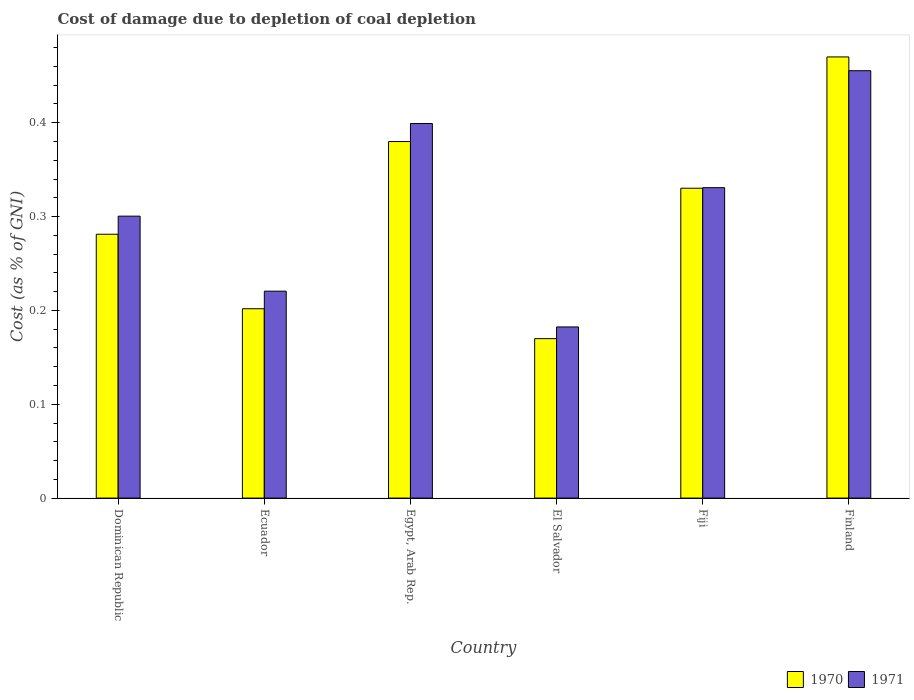How many different coloured bars are there?
Make the answer very short. 2. Are the number of bars per tick equal to the number of legend labels?
Ensure brevity in your answer.  Yes. Are the number of bars on each tick of the X-axis equal?
Give a very brief answer. Yes. How many bars are there on the 3rd tick from the left?
Your answer should be very brief. 2. How many bars are there on the 6th tick from the right?
Give a very brief answer. 2. What is the label of the 4th group of bars from the left?
Your answer should be very brief. El Salvador. In how many cases, is the number of bars for a given country not equal to the number of legend labels?
Make the answer very short. 0. What is the cost of damage caused due to coal depletion in 1971 in Egypt, Arab Rep.?
Provide a succinct answer. 0.4. Across all countries, what is the maximum cost of damage caused due to coal depletion in 1970?
Ensure brevity in your answer.  0.47. Across all countries, what is the minimum cost of damage caused due to coal depletion in 1970?
Offer a terse response. 0.17. In which country was the cost of damage caused due to coal depletion in 1971 maximum?
Make the answer very short. Finland. In which country was the cost of damage caused due to coal depletion in 1970 minimum?
Make the answer very short. El Salvador. What is the total cost of damage caused due to coal depletion in 1970 in the graph?
Give a very brief answer. 1.83. What is the difference between the cost of damage caused due to coal depletion in 1970 in Ecuador and that in El Salvador?
Your answer should be compact. 0.03. What is the difference between the cost of damage caused due to coal depletion in 1971 in Dominican Republic and the cost of damage caused due to coal depletion in 1970 in Egypt, Arab Rep.?
Offer a very short reply. -0.08. What is the average cost of damage caused due to coal depletion in 1971 per country?
Ensure brevity in your answer.  0.31. What is the difference between the cost of damage caused due to coal depletion of/in 1971 and cost of damage caused due to coal depletion of/in 1970 in Dominican Republic?
Your answer should be compact. 0.02. In how many countries, is the cost of damage caused due to coal depletion in 1971 greater than 0.24000000000000002 %?
Your answer should be compact. 4. What is the ratio of the cost of damage caused due to coal depletion in 1970 in Dominican Republic to that in Egypt, Arab Rep.?
Offer a very short reply. 0.74. Is the cost of damage caused due to coal depletion in 1971 in Dominican Republic less than that in El Salvador?
Give a very brief answer. No. Is the difference between the cost of damage caused due to coal depletion in 1971 in Ecuador and Fiji greater than the difference between the cost of damage caused due to coal depletion in 1970 in Ecuador and Fiji?
Make the answer very short. Yes. What is the difference between the highest and the second highest cost of damage caused due to coal depletion in 1970?
Your answer should be very brief. 0.09. What is the difference between the highest and the lowest cost of damage caused due to coal depletion in 1970?
Your answer should be very brief. 0.3. In how many countries, is the cost of damage caused due to coal depletion in 1970 greater than the average cost of damage caused due to coal depletion in 1970 taken over all countries?
Your answer should be very brief. 3. Is the sum of the cost of damage caused due to coal depletion in 1971 in Ecuador and Fiji greater than the maximum cost of damage caused due to coal depletion in 1970 across all countries?
Keep it short and to the point. Yes. What does the 1st bar from the right in El Salvador represents?
Provide a short and direct response. 1971. Are all the bars in the graph horizontal?
Offer a very short reply. No. Are the values on the major ticks of Y-axis written in scientific E-notation?
Your answer should be very brief. No. Does the graph contain any zero values?
Offer a very short reply. No. Where does the legend appear in the graph?
Offer a very short reply. Bottom right. How many legend labels are there?
Provide a short and direct response. 2. What is the title of the graph?
Give a very brief answer. Cost of damage due to depletion of coal depletion. What is the label or title of the X-axis?
Offer a terse response. Country. What is the label or title of the Y-axis?
Offer a terse response. Cost (as % of GNI). What is the Cost (as % of GNI) of 1970 in Dominican Republic?
Offer a terse response. 0.28. What is the Cost (as % of GNI) in 1971 in Dominican Republic?
Ensure brevity in your answer.  0.3. What is the Cost (as % of GNI) in 1970 in Ecuador?
Your response must be concise. 0.2. What is the Cost (as % of GNI) in 1971 in Ecuador?
Provide a short and direct response. 0.22. What is the Cost (as % of GNI) in 1970 in Egypt, Arab Rep.?
Provide a short and direct response. 0.38. What is the Cost (as % of GNI) of 1971 in Egypt, Arab Rep.?
Your answer should be compact. 0.4. What is the Cost (as % of GNI) in 1970 in El Salvador?
Provide a succinct answer. 0.17. What is the Cost (as % of GNI) in 1971 in El Salvador?
Provide a succinct answer. 0.18. What is the Cost (as % of GNI) of 1970 in Fiji?
Keep it short and to the point. 0.33. What is the Cost (as % of GNI) of 1971 in Fiji?
Provide a short and direct response. 0.33. What is the Cost (as % of GNI) of 1970 in Finland?
Ensure brevity in your answer.  0.47. What is the Cost (as % of GNI) of 1971 in Finland?
Keep it short and to the point. 0.46. Across all countries, what is the maximum Cost (as % of GNI) in 1970?
Provide a succinct answer. 0.47. Across all countries, what is the maximum Cost (as % of GNI) of 1971?
Offer a terse response. 0.46. Across all countries, what is the minimum Cost (as % of GNI) in 1970?
Offer a terse response. 0.17. Across all countries, what is the minimum Cost (as % of GNI) in 1971?
Your answer should be compact. 0.18. What is the total Cost (as % of GNI) of 1970 in the graph?
Your response must be concise. 1.83. What is the total Cost (as % of GNI) in 1971 in the graph?
Your response must be concise. 1.89. What is the difference between the Cost (as % of GNI) of 1970 in Dominican Republic and that in Ecuador?
Make the answer very short. 0.08. What is the difference between the Cost (as % of GNI) of 1971 in Dominican Republic and that in Ecuador?
Provide a short and direct response. 0.08. What is the difference between the Cost (as % of GNI) of 1970 in Dominican Republic and that in Egypt, Arab Rep.?
Your answer should be very brief. -0.1. What is the difference between the Cost (as % of GNI) in 1971 in Dominican Republic and that in Egypt, Arab Rep.?
Offer a terse response. -0.1. What is the difference between the Cost (as % of GNI) in 1970 in Dominican Republic and that in El Salvador?
Ensure brevity in your answer.  0.11. What is the difference between the Cost (as % of GNI) of 1971 in Dominican Republic and that in El Salvador?
Make the answer very short. 0.12. What is the difference between the Cost (as % of GNI) of 1970 in Dominican Republic and that in Fiji?
Give a very brief answer. -0.05. What is the difference between the Cost (as % of GNI) in 1971 in Dominican Republic and that in Fiji?
Ensure brevity in your answer.  -0.03. What is the difference between the Cost (as % of GNI) in 1970 in Dominican Republic and that in Finland?
Keep it short and to the point. -0.19. What is the difference between the Cost (as % of GNI) in 1971 in Dominican Republic and that in Finland?
Make the answer very short. -0.15. What is the difference between the Cost (as % of GNI) of 1970 in Ecuador and that in Egypt, Arab Rep.?
Provide a short and direct response. -0.18. What is the difference between the Cost (as % of GNI) in 1971 in Ecuador and that in Egypt, Arab Rep.?
Give a very brief answer. -0.18. What is the difference between the Cost (as % of GNI) in 1970 in Ecuador and that in El Salvador?
Provide a succinct answer. 0.03. What is the difference between the Cost (as % of GNI) of 1971 in Ecuador and that in El Salvador?
Offer a terse response. 0.04. What is the difference between the Cost (as % of GNI) of 1970 in Ecuador and that in Fiji?
Your answer should be very brief. -0.13. What is the difference between the Cost (as % of GNI) in 1971 in Ecuador and that in Fiji?
Give a very brief answer. -0.11. What is the difference between the Cost (as % of GNI) in 1970 in Ecuador and that in Finland?
Offer a very short reply. -0.27. What is the difference between the Cost (as % of GNI) of 1971 in Ecuador and that in Finland?
Offer a very short reply. -0.23. What is the difference between the Cost (as % of GNI) in 1970 in Egypt, Arab Rep. and that in El Salvador?
Offer a terse response. 0.21. What is the difference between the Cost (as % of GNI) of 1971 in Egypt, Arab Rep. and that in El Salvador?
Provide a short and direct response. 0.22. What is the difference between the Cost (as % of GNI) of 1970 in Egypt, Arab Rep. and that in Fiji?
Your answer should be compact. 0.05. What is the difference between the Cost (as % of GNI) in 1971 in Egypt, Arab Rep. and that in Fiji?
Your answer should be very brief. 0.07. What is the difference between the Cost (as % of GNI) of 1970 in Egypt, Arab Rep. and that in Finland?
Your answer should be very brief. -0.09. What is the difference between the Cost (as % of GNI) of 1971 in Egypt, Arab Rep. and that in Finland?
Your answer should be very brief. -0.06. What is the difference between the Cost (as % of GNI) of 1970 in El Salvador and that in Fiji?
Keep it short and to the point. -0.16. What is the difference between the Cost (as % of GNI) of 1971 in El Salvador and that in Fiji?
Keep it short and to the point. -0.15. What is the difference between the Cost (as % of GNI) of 1970 in El Salvador and that in Finland?
Give a very brief answer. -0.3. What is the difference between the Cost (as % of GNI) in 1971 in El Salvador and that in Finland?
Offer a very short reply. -0.27. What is the difference between the Cost (as % of GNI) in 1970 in Fiji and that in Finland?
Keep it short and to the point. -0.14. What is the difference between the Cost (as % of GNI) of 1971 in Fiji and that in Finland?
Offer a very short reply. -0.12. What is the difference between the Cost (as % of GNI) of 1970 in Dominican Republic and the Cost (as % of GNI) of 1971 in Ecuador?
Your answer should be compact. 0.06. What is the difference between the Cost (as % of GNI) of 1970 in Dominican Republic and the Cost (as % of GNI) of 1971 in Egypt, Arab Rep.?
Provide a succinct answer. -0.12. What is the difference between the Cost (as % of GNI) in 1970 in Dominican Republic and the Cost (as % of GNI) in 1971 in El Salvador?
Give a very brief answer. 0.1. What is the difference between the Cost (as % of GNI) of 1970 in Dominican Republic and the Cost (as % of GNI) of 1971 in Fiji?
Offer a terse response. -0.05. What is the difference between the Cost (as % of GNI) in 1970 in Dominican Republic and the Cost (as % of GNI) in 1971 in Finland?
Your response must be concise. -0.17. What is the difference between the Cost (as % of GNI) of 1970 in Ecuador and the Cost (as % of GNI) of 1971 in Egypt, Arab Rep.?
Keep it short and to the point. -0.2. What is the difference between the Cost (as % of GNI) of 1970 in Ecuador and the Cost (as % of GNI) of 1971 in El Salvador?
Provide a short and direct response. 0.02. What is the difference between the Cost (as % of GNI) in 1970 in Ecuador and the Cost (as % of GNI) in 1971 in Fiji?
Ensure brevity in your answer.  -0.13. What is the difference between the Cost (as % of GNI) of 1970 in Ecuador and the Cost (as % of GNI) of 1971 in Finland?
Offer a very short reply. -0.25. What is the difference between the Cost (as % of GNI) of 1970 in Egypt, Arab Rep. and the Cost (as % of GNI) of 1971 in El Salvador?
Make the answer very short. 0.2. What is the difference between the Cost (as % of GNI) of 1970 in Egypt, Arab Rep. and the Cost (as % of GNI) of 1971 in Fiji?
Give a very brief answer. 0.05. What is the difference between the Cost (as % of GNI) in 1970 in Egypt, Arab Rep. and the Cost (as % of GNI) in 1971 in Finland?
Make the answer very short. -0.08. What is the difference between the Cost (as % of GNI) of 1970 in El Salvador and the Cost (as % of GNI) of 1971 in Fiji?
Provide a succinct answer. -0.16. What is the difference between the Cost (as % of GNI) of 1970 in El Salvador and the Cost (as % of GNI) of 1971 in Finland?
Your answer should be very brief. -0.29. What is the difference between the Cost (as % of GNI) of 1970 in Fiji and the Cost (as % of GNI) of 1971 in Finland?
Offer a terse response. -0.13. What is the average Cost (as % of GNI) of 1970 per country?
Provide a succinct answer. 0.31. What is the average Cost (as % of GNI) of 1971 per country?
Make the answer very short. 0.31. What is the difference between the Cost (as % of GNI) of 1970 and Cost (as % of GNI) of 1971 in Dominican Republic?
Give a very brief answer. -0.02. What is the difference between the Cost (as % of GNI) of 1970 and Cost (as % of GNI) of 1971 in Ecuador?
Offer a terse response. -0.02. What is the difference between the Cost (as % of GNI) of 1970 and Cost (as % of GNI) of 1971 in Egypt, Arab Rep.?
Keep it short and to the point. -0.02. What is the difference between the Cost (as % of GNI) of 1970 and Cost (as % of GNI) of 1971 in El Salvador?
Offer a very short reply. -0.01. What is the difference between the Cost (as % of GNI) of 1970 and Cost (as % of GNI) of 1971 in Fiji?
Provide a short and direct response. -0. What is the difference between the Cost (as % of GNI) of 1970 and Cost (as % of GNI) of 1971 in Finland?
Give a very brief answer. 0.01. What is the ratio of the Cost (as % of GNI) of 1970 in Dominican Republic to that in Ecuador?
Give a very brief answer. 1.39. What is the ratio of the Cost (as % of GNI) of 1971 in Dominican Republic to that in Ecuador?
Provide a short and direct response. 1.36. What is the ratio of the Cost (as % of GNI) in 1970 in Dominican Republic to that in Egypt, Arab Rep.?
Give a very brief answer. 0.74. What is the ratio of the Cost (as % of GNI) of 1971 in Dominican Republic to that in Egypt, Arab Rep.?
Provide a short and direct response. 0.75. What is the ratio of the Cost (as % of GNI) in 1970 in Dominican Republic to that in El Salvador?
Ensure brevity in your answer.  1.65. What is the ratio of the Cost (as % of GNI) of 1971 in Dominican Republic to that in El Salvador?
Your answer should be compact. 1.65. What is the ratio of the Cost (as % of GNI) of 1970 in Dominican Republic to that in Fiji?
Keep it short and to the point. 0.85. What is the ratio of the Cost (as % of GNI) in 1971 in Dominican Republic to that in Fiji?
Make the answer very short. 0.91. What is the ratio of the Cost (as % of GNI) of 1970 in Dominican Republic to that in Finland?
Provide a short and direct response. 0.6. What is the ratio of the Cost (as % of GNI) of 1971 in Dominican Republic to that in Finland?
Give a very brief answer. 0.66. What is the ratio of the Cost (as % of GNI) in 1970 in Ecuador to that in Egypt, Arab Rep.?
Your answer should be very brief. 0.53. What is the ratio of the Cost (as % of GNI) of 1971 in Ecuador to that in Egypt, Arab Rep.?
Ensure brevity in your answer.  0.55. What is the ratio of the Cost (as % of GNI) of 1970 in Ecuador to that in El Salvador?
Your response must be concise. 1.19. What is the ratio of the Cost (as % of GNI) of 1971 in Ecuador to that in El Salvador?
Offer a very short reply. 1.21. What is the ratio of the Cost (as % of GNI) in 1970 in Ecuador to that in Fiji?
Your response must be concise. 0.61. What is the ratio of the Cost (as % of GNI) of 1971 in Ecuador to that in Fiji?
Make the answer very short. 0.67. What is the ratio of the Cost (as % of GNI) of 1970 in Ecuador to that in Finland?
Your answer should be very brief. 0.43. What is the ratio of the Cost (as % of GNI) of 1971 in Ecuador to that in Finland?
Offer a very short reply. 0.48. What is the ratio of the Cost (as % of GNI) of 1970 in Egypt, Arab Rep. to that in El Salvador?
Your answer should be very brief. 2.24. What is the ratio of the Cost (as % of GNI) in 1971 in Egypt, Arab Rep. to that in El Salvador?
Give a very brief answer. 2.19. What is the ratio of the Cost (as % of GNI) of 1970 in Egypt, Arab Rep. to that in Fiji?
Your answer should be compact. 1.15. What is the ratio of the Cost (as % of GNI) in 1971 in Egypt, Arab Rep. to that in Fiji?
Your answer should be compact. 1.21. What is the ratio of the Cost (as % of GNI) of 1970 in Egypt, Arab Rep. to that in Finland?
Offer a terse response. 0.81. What is the ratio of the Cost (as % of GNI) of 1971 in Egypt, Arab Rep. to that in Finland?
Keep it short and to the point. 0.88. What is the ratio of the Cost (as % of GNI) in 1970 in El Salvador to that in Fiji?
Give a very brief answer. 0.51. What is the ratio of the Cost (as % of GNI) of 1971 in El Salvador to that in Fiji?
Your answer should be very brief. 0.55. What is the ratio of the Cost (as % of GNI) in 1970 in El Salvador to that in Finland?
Make the answer very short. 0.36. What is the ratio of the Cost (as % of GNI) of 1971 in El Salvador to that in Finland?
Offer a terse response. 0.4. What is the ratio of the Cost (as % of GNI) in 1970 in Fiji to that in Finland?
Your answer should be very brief. 0.7. What is the ratio of the Cost (as % of GNI) of 1971 in Fiji to that in Finland?
Your response must be concise. 0.73. What is the difference between the highest and the second highest Cost (as % of GNI) of 1970?
Keep it short and to the point. 0.09. What is the difference between the highest and the second highest Cost (as % of GNI) of 1971?
Provide a short and direct response. 0.06. What is the difference between the highest and the lowest Cost (as % of GNI) in 1970?
Your answer should be very brief. 0.3. What is the difference between the highest and the lowest Cost (as % of GNI) in 1971?
Keep it short and to the point. 0.27. 